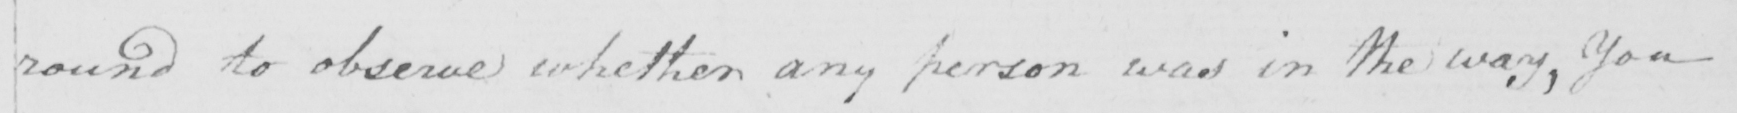Transcribe the text shown in this historical manuscript line. round to observe whether any person was in the way , you 